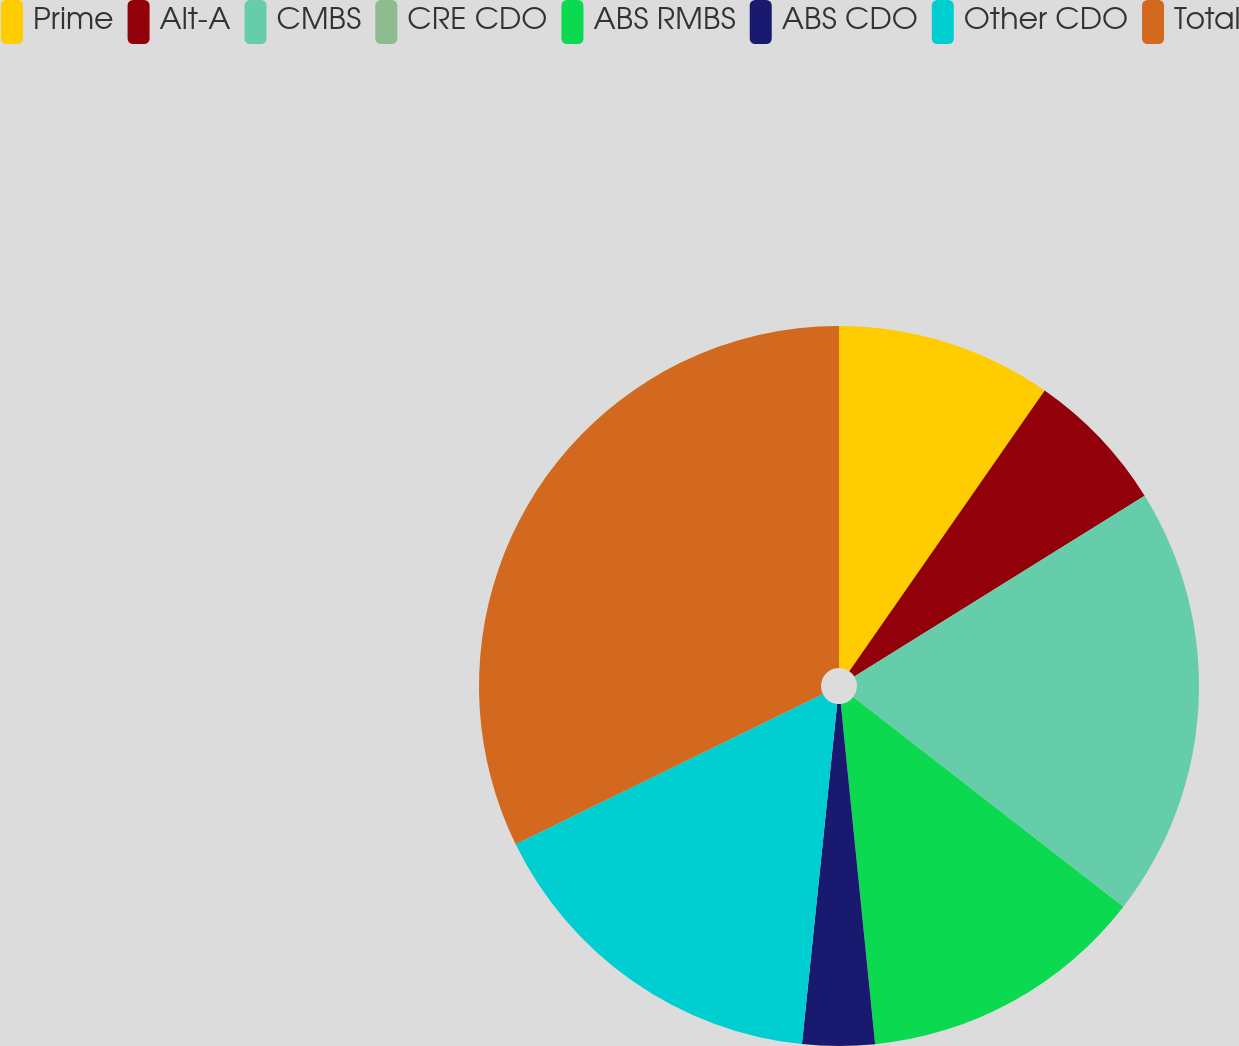Convert chart to OTSL. <chart><loc_0><loc_0><loc_500><loc_500><pie_chart><fcel>Prime<fcel>Alt-A<fcel>CMBS<fcel>CRE CDO<fcel>ABS RMBS<fcel>ABS CDO<fcel>Other CDO<fcel>Total<nl><fcel>9.68%<fcel>6.46%<fcel>19.35%<fcel>0.01%<fcel>12.9%<fcel>3.24%<fcel>16.12%<fcel>32.24%<nl></chart> 